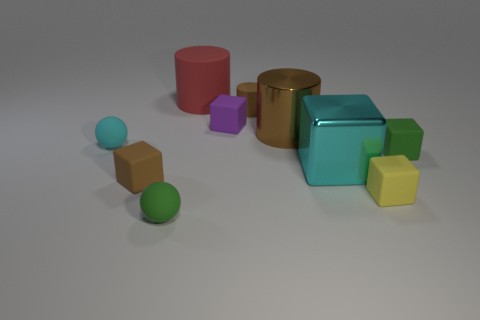Is the material of the small green cube the same as the red cylinder?
Give a very brief answer. Yes. Is there anything else that is made of the same material as the small green sphere?
Offer a very short reply. Yes. There is a large cyan object that is the same shape as the yellow matte object; what is it made of?
Keep it short and to the point. Metal. Are there fewer tiny yellow cubes on the left side of the green rubber sphere than purple cubes?
Provide a succinct answer. Yes. There is a red rubber cylinder; how many large shiny blocks are on the left side of it?
Make the answer very short. 0. There is a brown rubber thing that is in front of the small cyan matte sphere; is its shape the same as the large thing on the left side of the tiny rubber cylinder?
Offer a terse response. No. There is a object that is behind the large brown metallic object and left of the purple cube; what shape is it?
Your answer should be compact. Cylinder. There is a green block that is the same material as the tiny yellow thing; what is its size?
Ensure brevity in your answer.  Small. Are there fewer cyan balls than large blue things?
Provide a short and direct response. No. What material is the small green object that is right of the small ball that is to the right of the tiny matte cube left of the purple rubber cube?
Make the answer very short. Rubber. 